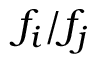Convert formula to latex. <formula><loc_0><loc_0><loc_500><loc_500>f _ { i } / f _ { j }</formula> 